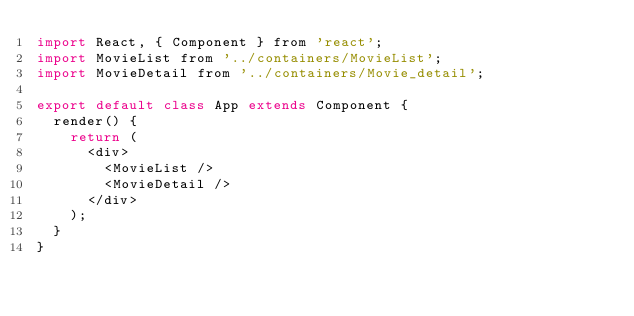<code> <loc_0><loc_0><loc_500><loc_500><_JavaScript_>import React, { Component } from 'react';
import MovieList from '../containers/MovieList';
import MovieDetail from '../containers/Movie_detail';

export default class App extends Component {
  render() {
    return (
      <div>
        <MovieList />
        <MovieDetail />
      </div>
    );
  }
}
</code> 